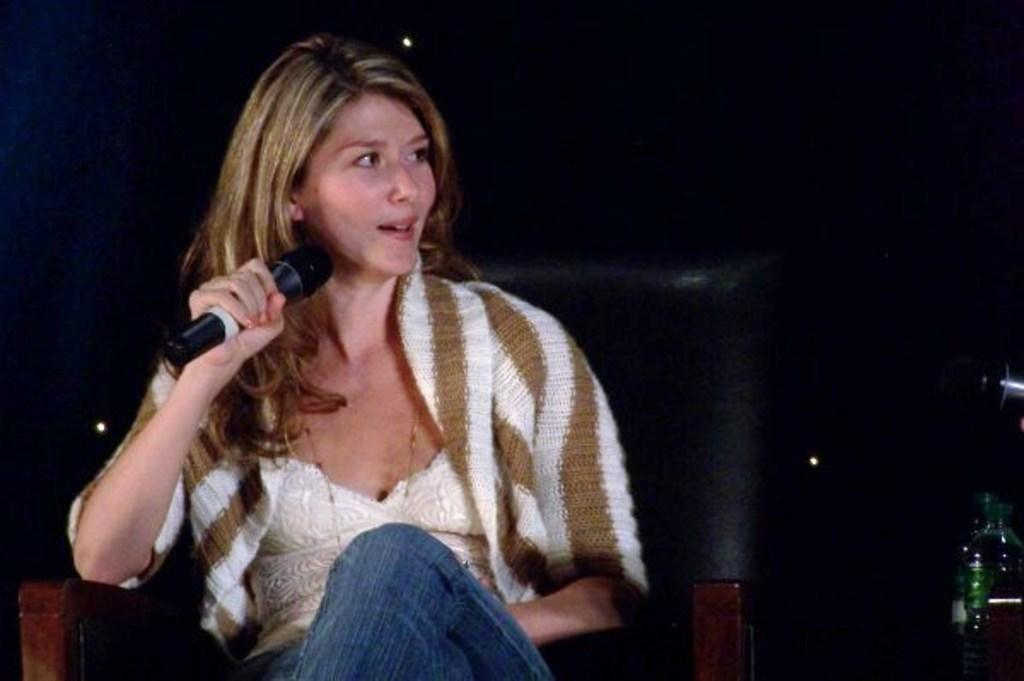Who is the main subject in the image? There is a woman in the image. What is the woman doing in the image? The woman is sitting on a chair and holding a mic. Are there any other objects visible in the image? Yes, there is a bottle in the image. What type of cord is connected to the mic in the image? There is no cord connected to the mic in the image; the woman is simply holding it. How many thumbs does the woman have in the image? The number of thumbs the woman has cannot be determined from the image. 